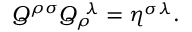<formula> <loc_0><loc_0><loc_500><loc_500>Q ^ { \rho \sigma } Q _ { \rho } ^ { \ \lambda } = \eta ^ { \sigma \lambda } .</formula> 